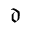<formula> <loc_0><loc_0><loc_500><loc_500>\mathfrak { d }</formula> 